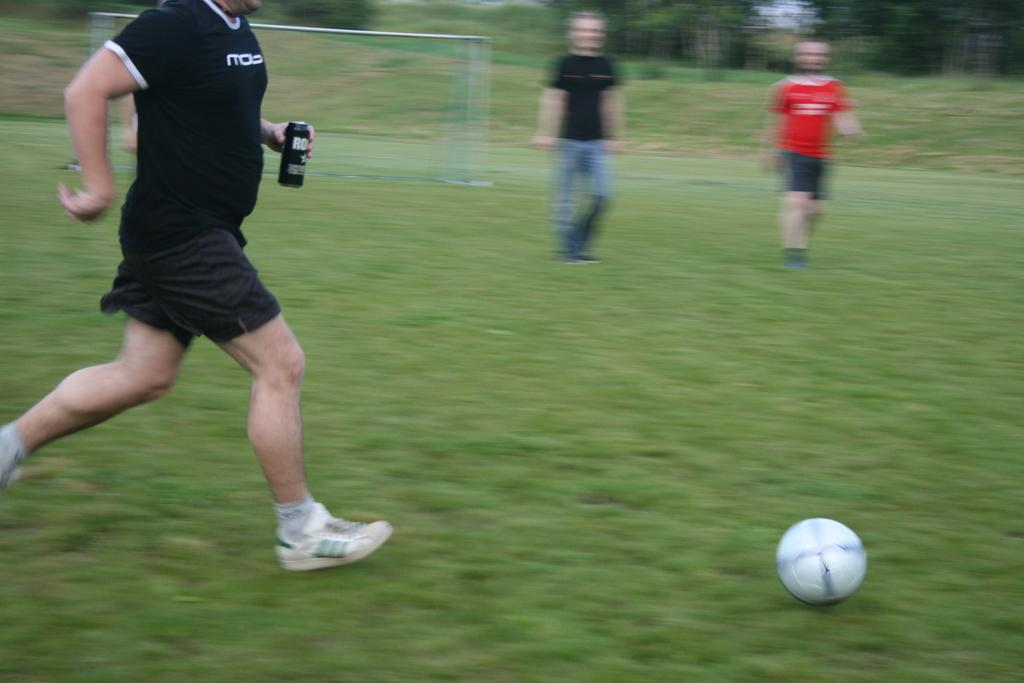What is the person in the image doing? The person is standing in the image and holding a bottle. What else can be seen on the ground in the image? There is a ball on the grass in the image. What is visible in the background of the image? There are trees and the sky visible in the background of the image. Can you see any cherries growing on the trees in the image? There is no mention of cherries or any fruit trees in the image; only trees are mentioned in the background. 